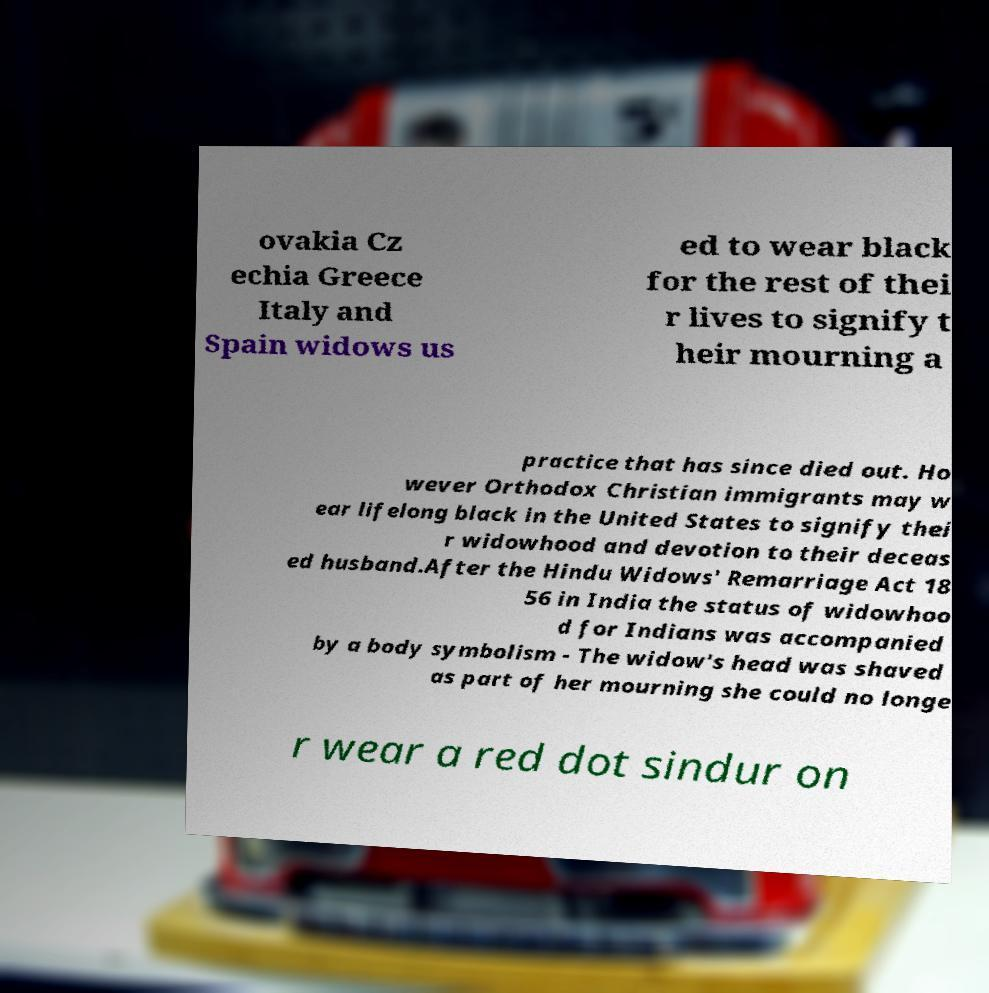Could you extract and type out the text from this image? ovakia Cz echia Greece Italy and Spain widows us ed to wear black for the rest of thei r lives to signify t heir mourning a practice that has since died out. Ho wever Orthodox Christian immigrants may w ear lifelong black in the United States to signify thei r widowhood and devotion to their deceas ed husband.After the Hindu Widows' Remarriage Act 18 56 in India the status of widowhoo d for Indians was accompanied by a body symbolism - The widow's head was shaved as part of her mourning she could no longe r wear a red dot sindur on 